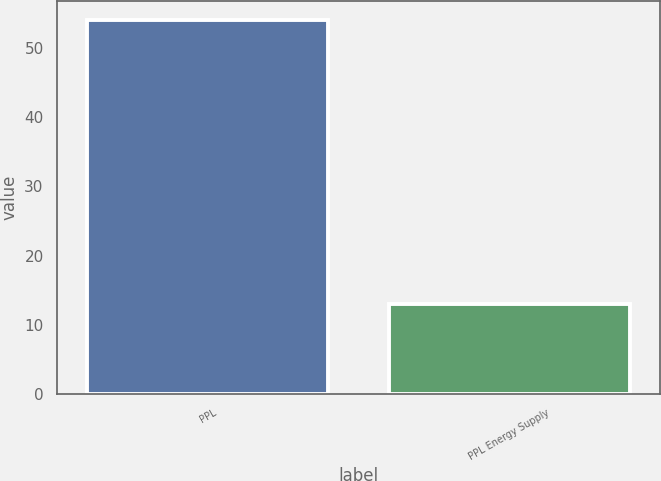Convert chart. <chart><loc_0><loc_0><loc_500><loc_500><bar_chart><fcel>PPL<fcel>PPL Energy Supply<nl><fcel>54<fcel>13<nl></chart> 